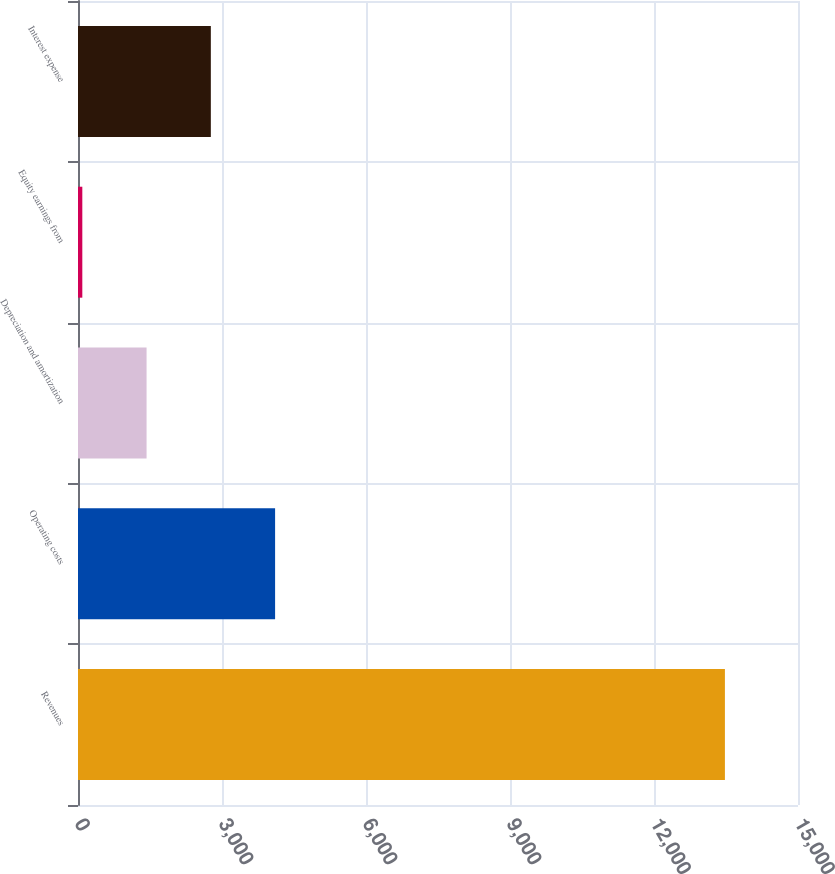<chart> <loc_0><loc_0><loc_500><loc_500><bar_chart><fcel>Revenues<fcel>Operating costs<fcel>Depreciation and amortization<fcel>Equity earnings from<fcel>Interest expense<nl><fcel>13477.4<fcel>4106.15<fcel>1428.65<fcel>89.9<fcel>2767.4<nl></chart> 